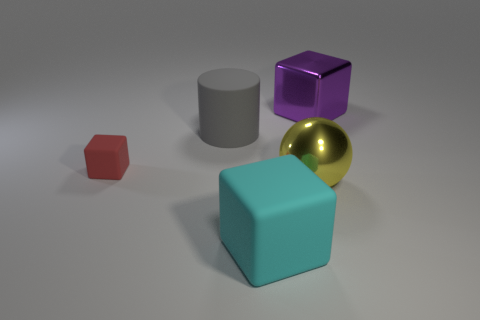Subtract all red cubes. How many cubes are left? 2 Add 2 metal things. How many objects exist? 7 Subtract all cyan cubes. How many cubes are left? 2 Subtract 2 cubes. How many cubes are left? 1 Subtract all blue blocks. Subtract all red cylinders. How many blocks are left? 3 Subtract all cylinders. How many objects are left? 4 Subtract all yellow cylinders. How many red blocks are left? 1 Subtract all large gray shiny balls. Subtract all large purple blocks. How many objects are left? 4 Add 5 yellow things. How many yellow things are left? 6 Add 4 purple metallic objects. How many purple metallic objects exist? 5 